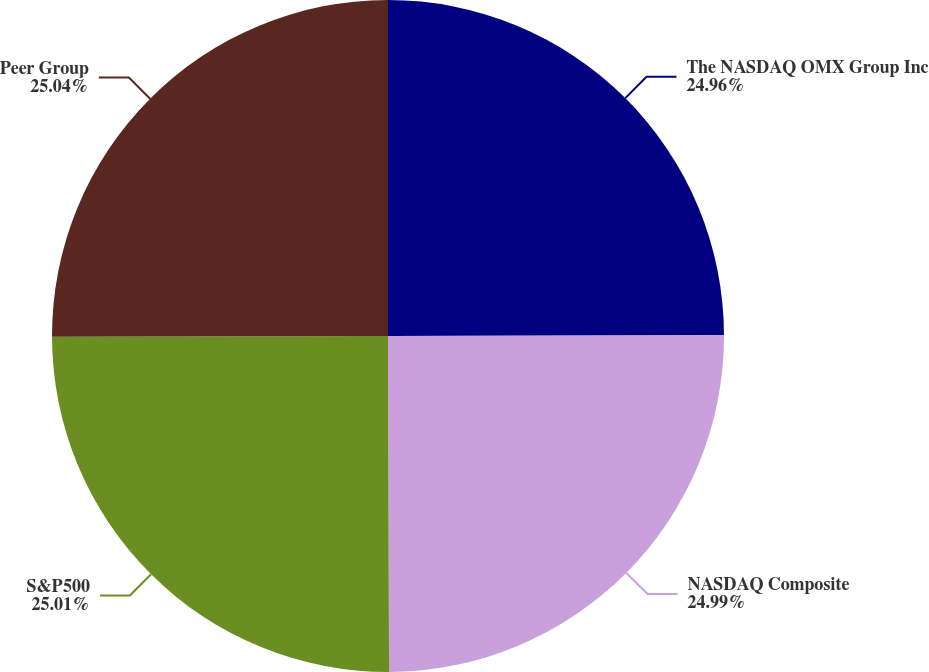<chart> <loc_0><loc_0><loc_500><loc_500><pie_chart><fcel>The NASDAQ OMX Group Inc<fcel>NASDAQ Composite<fcel>S&P500<fcel>Peer Group<nl><fcel>24.96%<fcel>24.99%<fcel>25.01%<fcel>25.04%<nl></chart> 